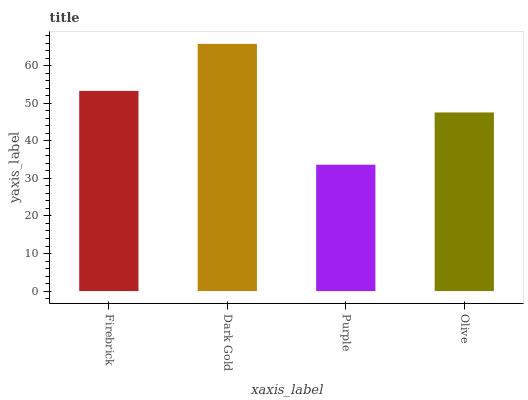Is Purple the minimum?
Answer yes or no. Yes. Is Dark Gold the maximum?
Answer yes or no. Yes. Is Dark Gold the minimum?
Answer yes or no. No. Is Purple the maximum?
Answer yes or no. No. Is Dark Gold greater than Purple?
Answer yes or no. Yes. Is Purple less than Dark Gold?
Answer yes or no. Yes. Is Purple greater than Dark Gold?
Answer yes or no. No. Is Dark Gold less than Purple?
Answer yes or no. No. Is Firebrick the high median?
Answer yes or no. Yes. Is Olive the low median?
Answer yes or no. Yes. Is Purple the high median?
Answer yes or no. No. Is Purple the low median?
Answer yes or no. No. 